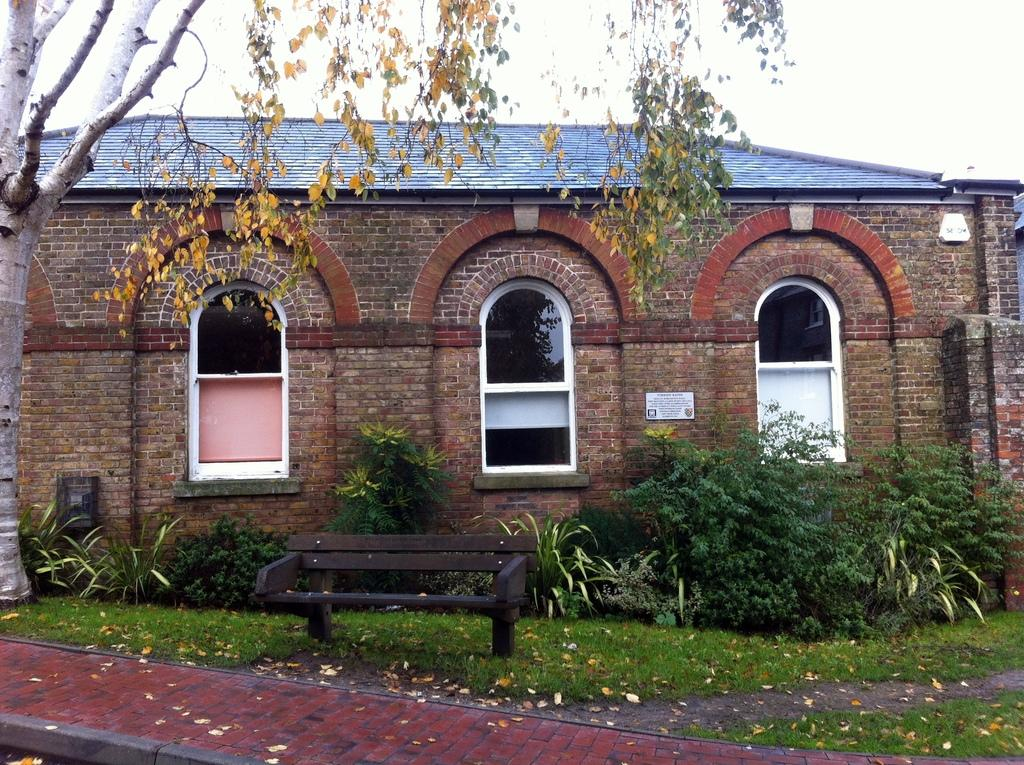What type of structure is visible in the image? There is a building in the image. What type of vegetation can be seen in the image? Plants, leaves, and a tree are present in the image. What part of the building can be seen in the image? There are windows visible in the image. What type of ground surface is visible in the image? Grass is visible in the image. What type of seating is present in the image? A bench is present in the image. What is visible in the background of the image? The sky is visible in the background of the image. What degree of difficulty is the tree in the image rated on a scale of 1 to 10? The image does not provide any information about the difficulty level of the tree, and therefore it cannot be rated on a scale of 1 to 10. What type of fabric is used to make the leaves in the image? The leaves in the image are not made of fabric; they are natural plant parts. 